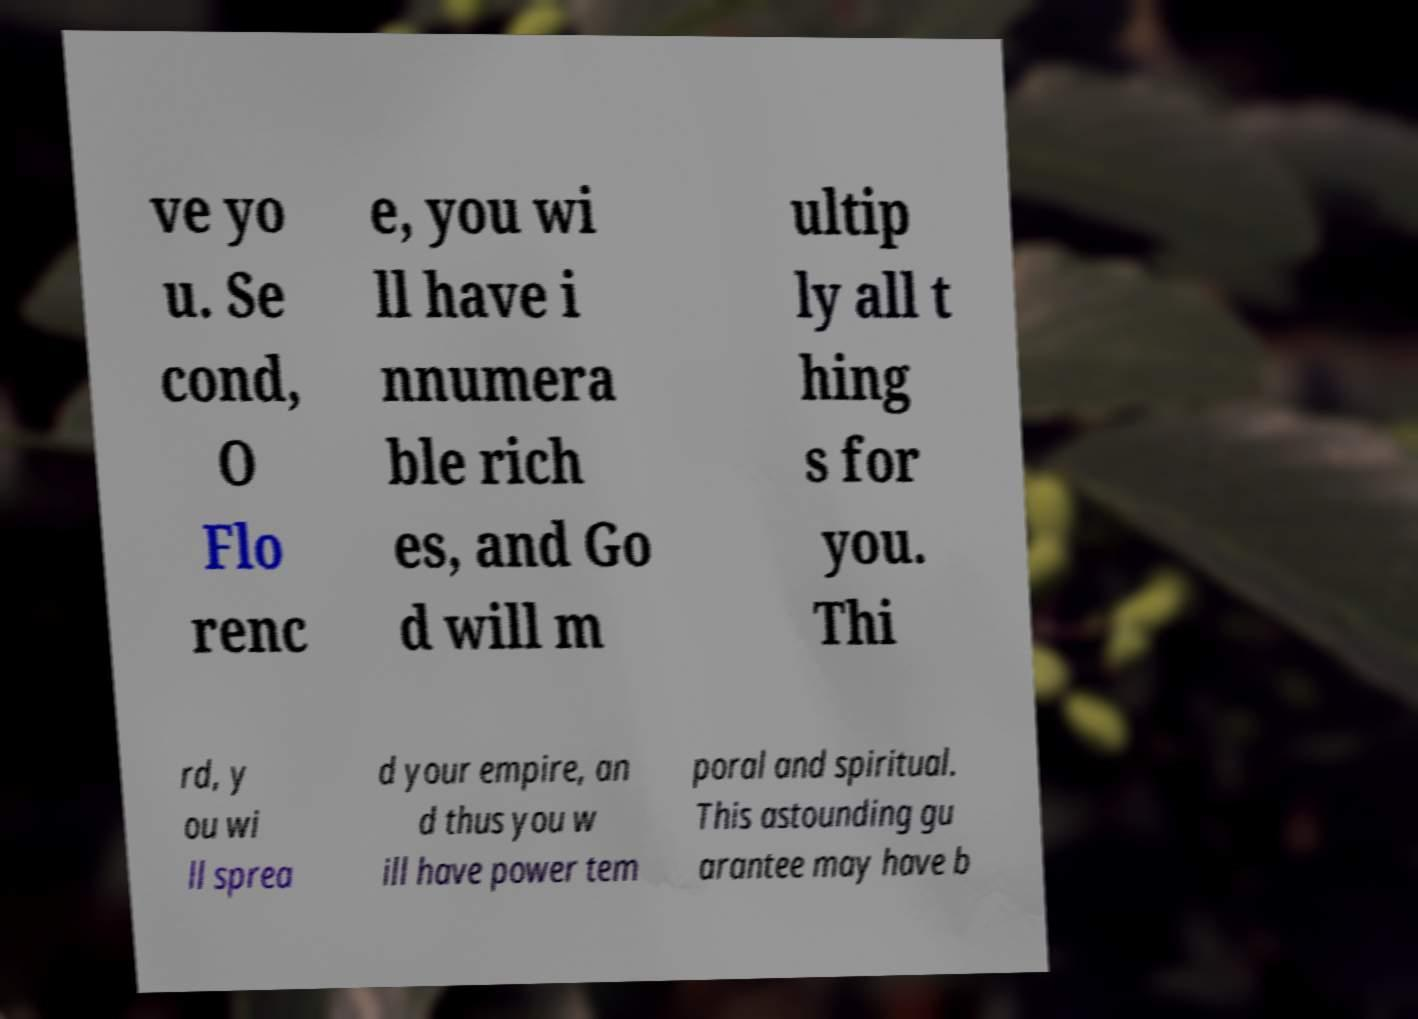Please read and relay the text visible in this image. What does it say? ve yo u. Se cond, O Flo renc e, you wi ll have i nnumera ble rich es, and Go d will m ultip ly all t hing s for you. Thi rd, y ou wi ll sprea d your empire, an d thus you w ill have power tem poral and spiritual. This astounding gu arantee may have b 